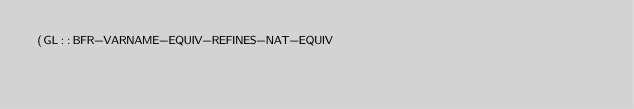<code> <loc_0><loc_0><loc_500><loc_500><_Lisp_>(GL::BFR-VARNAME-EQUIV-REFINES-NAT-EQUIV</code> 